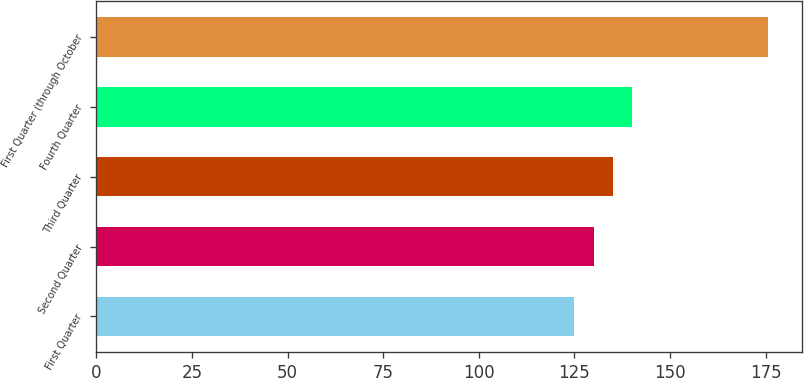Convert chart to OTSL. <chart><loc_0><loc_0><loc_500><loc_500><bar_chart><fcel>First Quarter<fcel>Second Quarter<fcel>Third Quarter<fcel>Fourth Quarter<fcel>First Quarter (through October<nl><fcel>124.96<fcel>130.03<fcel>135.1<fcel>140.17<fcel>175.64<nl></chart> 